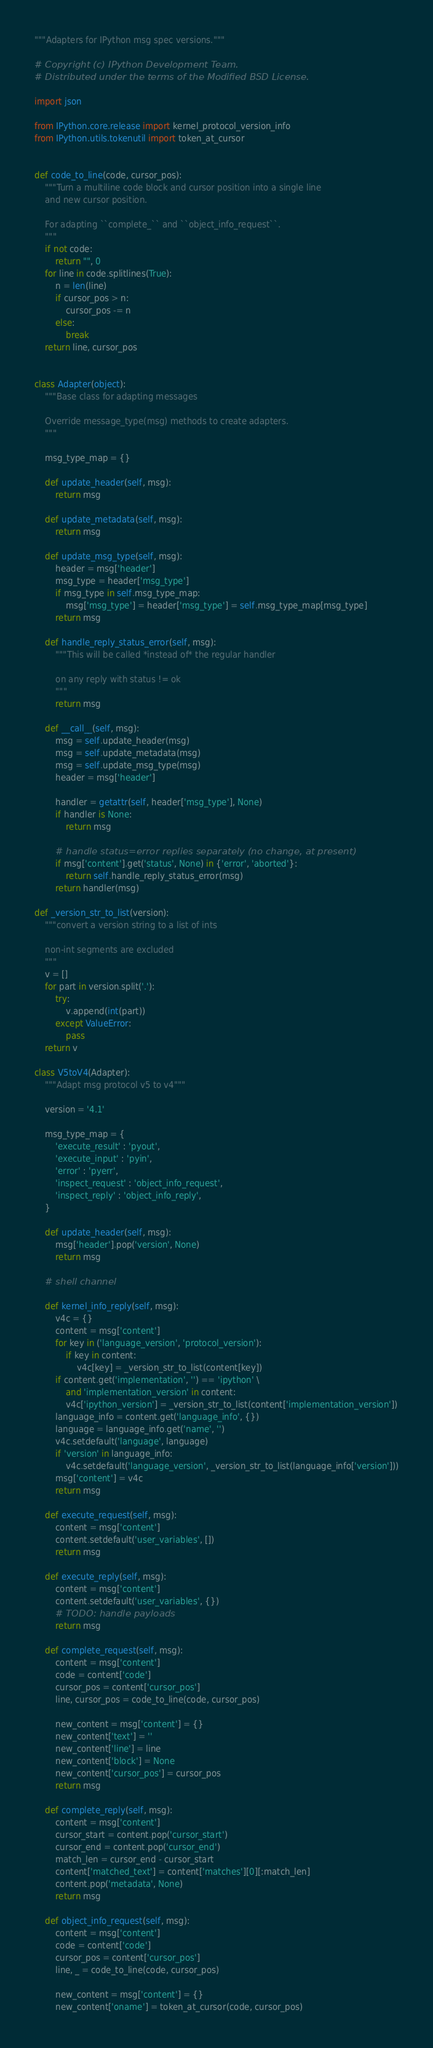Convert code to text. <code><loc_0><loc_0><loc_500><loc_500><_Python_>"""Adapters for IPython msg spec versions."""

# Copyright (c) IPython Development Team.
# Distributed under the terms of the Modified BSD License.

import json

from IPython.core.release import kernel_protocol_version_info
from IPython.utils.tokenutil import token_at_cursor


def code_to_line(code, cursor_pos):
    """Turn a multiline code block and cursor position into a single line
    and new cursor position.
    
    For adapting ``complete_`` and ``object_info_request``.
    """
    if not code:
        return "", 0
    for line in code.splitlines(True):
        n = len(line)
        if cursor_pos > n:
            cursor_pos -= n
        else:
            break
    return line, cursor_pos


class Adapter(object):
    """Base class for adapting messages
    
    Override message_type(msg) methods to create adapters.
    """
    
    msg_type_map = {}
    
    def update_header(self, msg):
        return msg
    
    def update_metadata(self, msg):
        return msg
    
    def update_msg_type(self, msg):
        header = msg['header']
        msg_type = header['msg_type']
        if msg_type in self.msg_type_map:
            msg['msg_type'] = header['msg_type'] = self.msg_type_map[msg_type]
        return msg
    
    def handle_reply_status_error(self, msg):
        """This will be called *instead of* the regular handler
        
        on any reply with status != ok
        """
        return msg
    
    def __call__(self, msg):
        msg = self.update_header(msg)
        msg = self.update_metadata(msg)
        msg = self.update_msg_type(msg)
        header = msg['header']
        
        handler = getattr(self, header['msg_type'], None)
        if handler is None:
            return msg
        
        # handle status=error replies separately (no change, at present)
        if msg['content'].get('status', None) in {'error', 'aborted'}:
            return self.handle_reply_status_error(msg)
        return handler(msg)

def _version_str_to_list(version):
    """convert a version string to a list of ints
    
    non-int segments are excluded
    """
    v = []
    for part in version.split('.'):
        try:
            v.append(int(part))
        except ValueError:
            pass
    return v

class V5toV4(Adapter):
    """Adapt msg protocol v5 to v4"""
    
    version = '4.1'
    
    msg_type_map = {
        'execute_result' : 'pyout',
        'execute_input' : 'pyin',
        'error' : 'pyerr',
        'inspect_request' : 'object_info_request',
        'inspect_reply' : 'object_info_reply',
    }
    
    def update_header(self, msg):
        msg['header'].pop('version', None)
        return msg
    
    # shell channel
    
    def kernel_info_reply(self, msg):
        v4c = {}
        content = msg['content']
        for key in ('language_version', 'protocol_version'):
            if key in content:
                v4c[key] = _version_str_to_list(content[key])
        if content.get('implementation', '') == 'ipython' \
            and 'implementation_version' in content:
            v4c['ipython_version'] = _version_str_to_list(content['implementation_version'])
        language_info = content.get('language_info', {})
        language = language_info.get('name', '')
        v4c.setdefault('language', language)
        if 'version' in language_info:
            v4c.setdefault('language_version', _version_str_to_list(language_info['version']))
        msg['content'] = v4c
        return msg
    
    def execute_request(self, msg):
        content = msg['content']
        content.setdefault('user_variables', [])
        return msg
    
    def execute_reply(self, msg):
        content = msg['content']
        content.setdefault('user_variables', {})
        # TODO: handle payloads
        return msg
    
    def complete_request(self, msg):
        content = msg['content']
        code = content['code']
        cursor_pos = content['cursor_pos']
        line, cursor_pos = code_to_line(code, cursor_pos)
        
        new_content = msg['content'] = {}
        new_content['text'] = ''
        new_content['line'] = line
        new_content['block'] = None
        new_content['cursor_pos'] = cursor_pos
        return msg
    
    def complete_reply(self, msg):
        content = msg['content']
        cursor_start = content.pop('cursor_start')
        cursor_end = content.pop('cursor_end')
        match_len = cursor_end - cursor_start
        content['matched_text'] = content['matches'][0][:match_len]
        content.pop('metadata', None)
        return msg
    
    def object_info_request(self, msg):
        content = msg['content']
        code = content['code']
        cursor_pos = content['cursor_pos']
        line, _ = code_to_line(code, cursor_pos)
        
        new_content = msg['content'] = {}
        new_content['oname'] = token_at_cursor(code, cursor_pos)</code> 